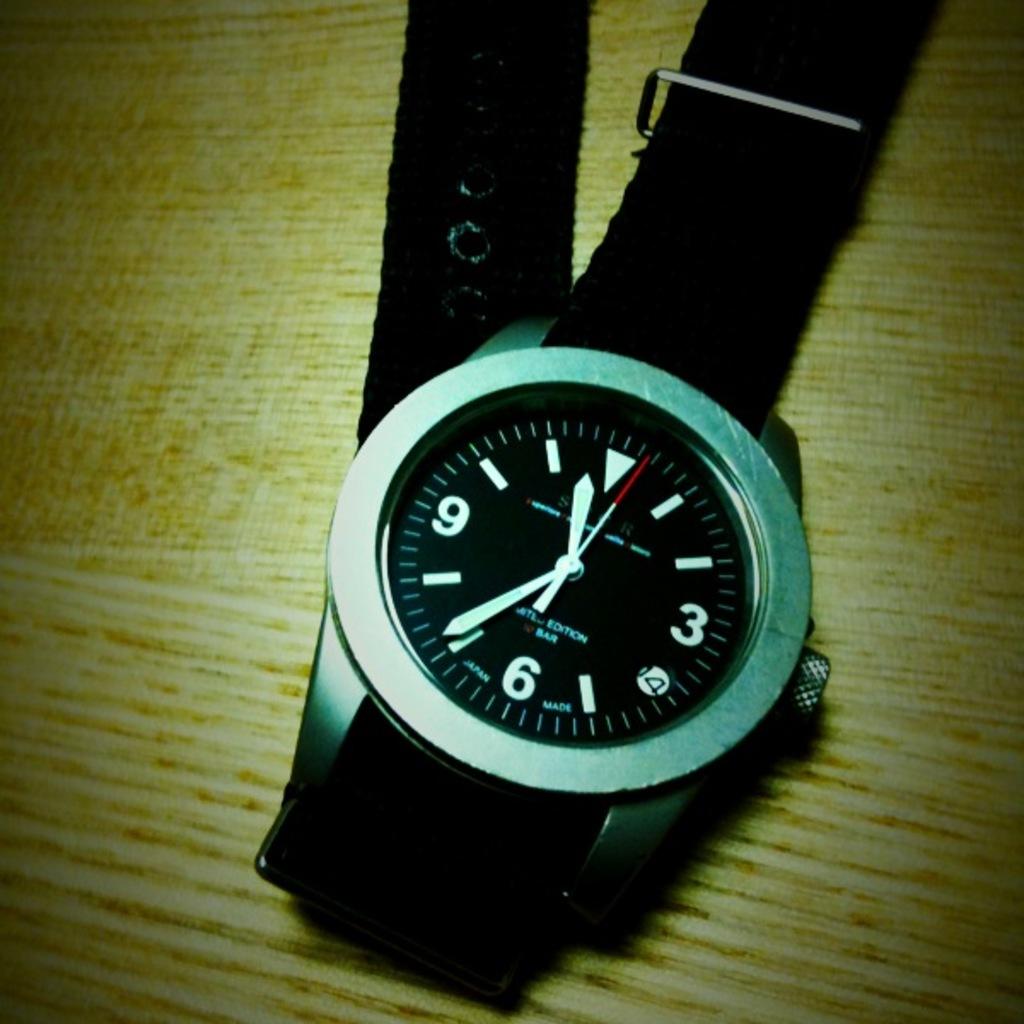What time does this watch show?
Ensure brevity in your answer.  11:36. What time ison the watch?
Provide a succinct answer. 11:36. 